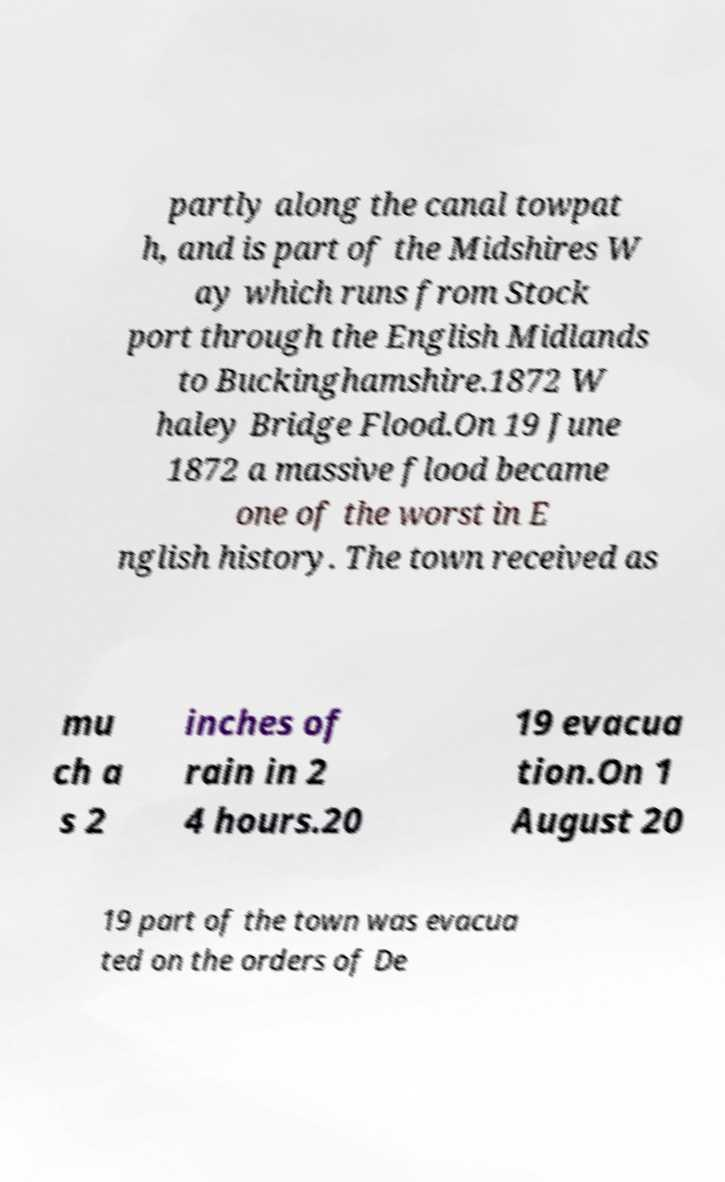Can you read and provide the text displayed in the image?This photo seems to have some interesting text. Can you extract and type it out for me? partly along the canal towpat h, and is part of the Midshires W ay which runs from Stock port through the English Midlands to Buckinghamshire.1872 W haley Bridge Flood.On 19 June 1872 a massive flood became one of the worst in E nglish history. The town received as mu ch a s 2 inches of rain in 2 4 hours.20 19 evacua tion.On 1 August 20 19 part of the town was evacua ted on the orders of De 